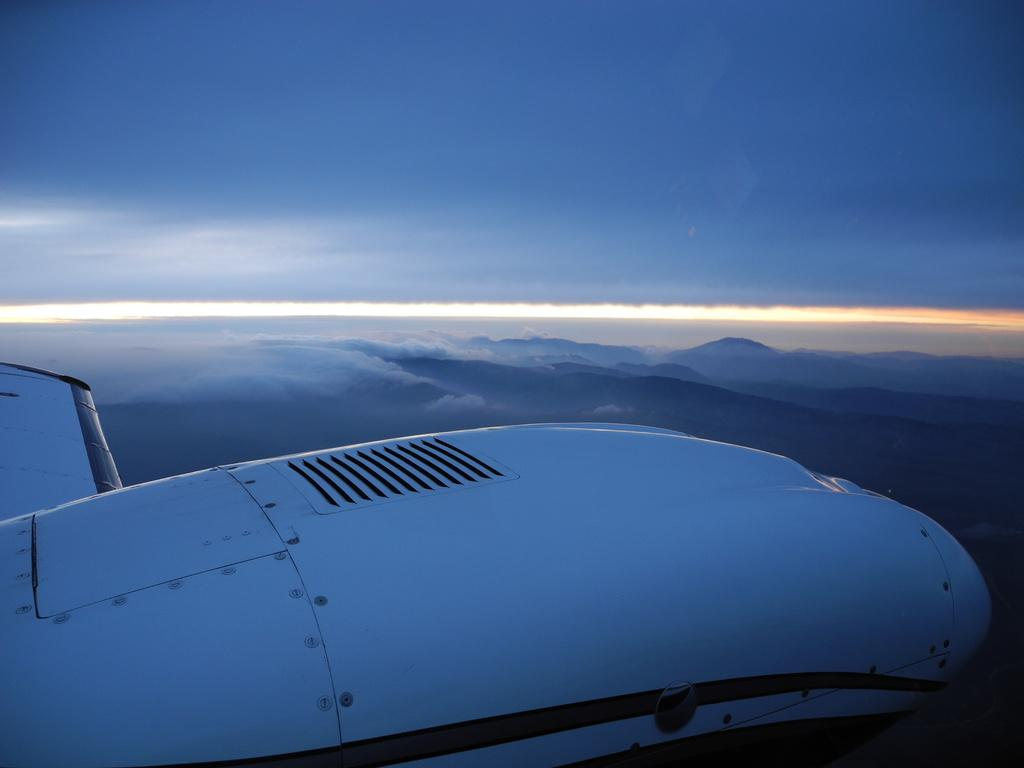What is the main subject of the picture? The main subject of the picture is an airplane. What is the color of the airplane? The airplane is white in color. What is the airplane doing in the picture? The airplane is flying in the sky. What can be seen in the background of the image? There are clouds visible in the background of the image. What is the color of the sky in the picture? The sky is blue in color. Where is the lamp located in the image? There is no lamp present in the image; it features an airplane flying in the sky. What type of cable is connected to the oven in the image? There is no oven or cable present in the image. 